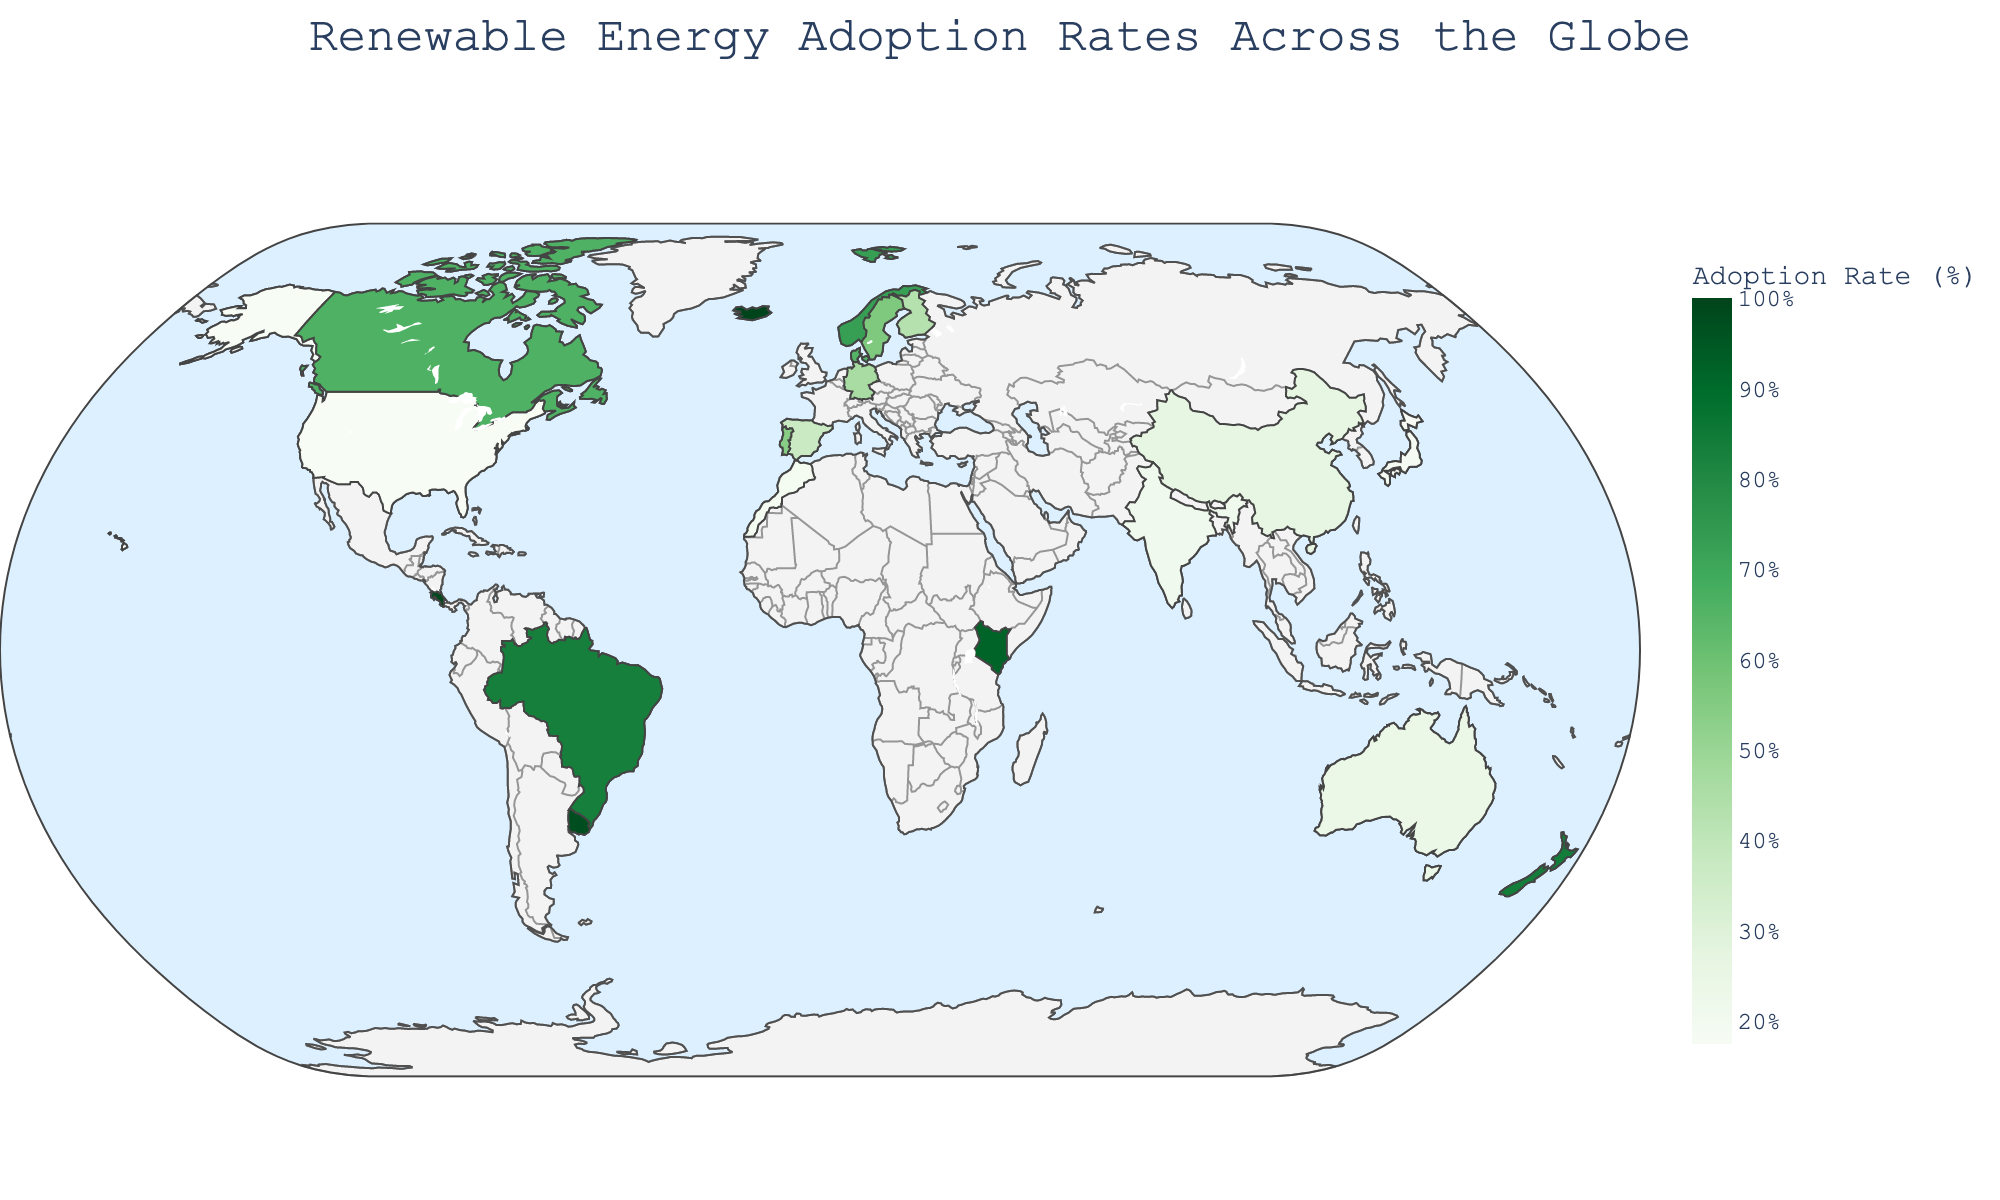How many countries have renewable energy adoption rates higher than 80%? Look at the color intensity on the map, identify countries with darker shades of green indicating higher adoption rates, and count them.
Answer: 5 Which country has the highest renewable energy adoption rate? What is this rate? Check the country with the darkest shade of green and the highest value in the color bar. According to the data, Iceland has the highest rate.
Answer: Iceland, 100.0% What is the average renewable energy adoption rate for countries in Northern Europe? Identify the countries in Northern Europe (Norway, Iceland, Sweden, Denmark, Finland) and calculate the average of their adoption rates [(72.8 + 100 + 56.4 + 65.3 + 43.1) / 5].
Answer: 67.52% Which region has the highest average renewable energy adoption rate, and what is that average? Calculate the average adoption rates for each region and determine the highest (Northern Europe, Western Europe, Central America, Oceania, South America, Eastern Africa, Eastern Asia, North America, Southern Asia, Southern Europe, Northern Africa).
Answer: Central America, 99.2% What is the difference in renewable energy adoption rates between Germany and Portugal? Locate Germany and Portugal on the map, note their respective adoption rates, and calculate the difference (46.3 - 54.2).
Answer: 7.9% Which country in North America has the higher renewable energy adoption rate? Compare the renewable energy adoption rates of countries in North America (United States and Canada) and identify the higher one.
Answer: Canada Is there a visible pattern in renewable energy adoption rates between continents? Observe the trend of color shades across different continents and comment on any apparent patterns (e.g., higher adoption rates in Europe and South America).
Answer: Higher in Europe, South America, and Oceania What is the renewable energy adoption rate of countries in Oceania? Identify the countries in Oceania (New Zealand and Australia) and note their adoption rates.
Answer: New Zealand: 84.0%, Australia: 24.2% How does the renewable energy adoption rate in China compare to the rest of Eastern Asia? Compare China's adoption rate (26.7%) with the rate of Japan in Eastern Asia (18.5%).
Answer: China has a higher rate than Japan What is the title of the geographic plot? Look at the top of the map where the title is usually positioned and read it.
Answer: Renewable Energy Adoption Rates Across the Globe 